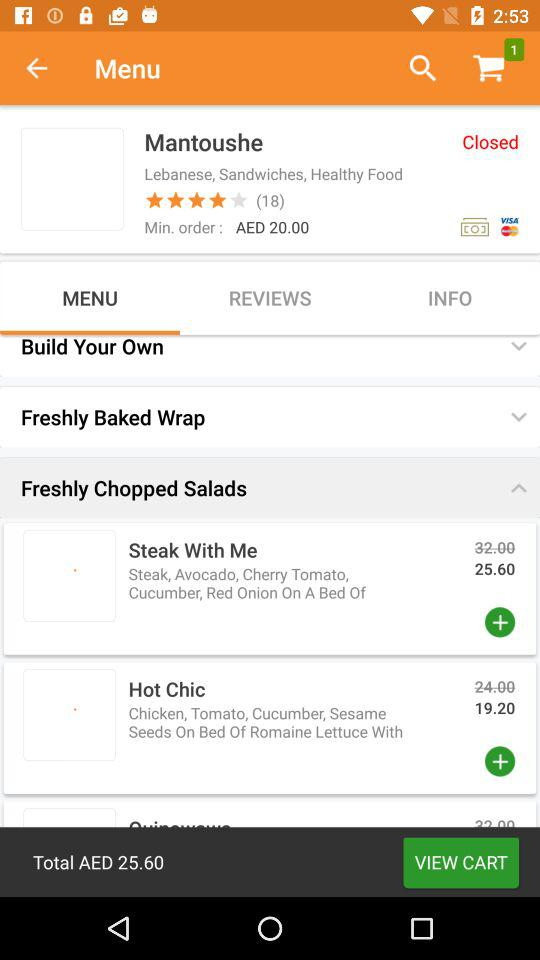What is the amount for the minimum order? The amount for the minimum order is AED 20.00. 